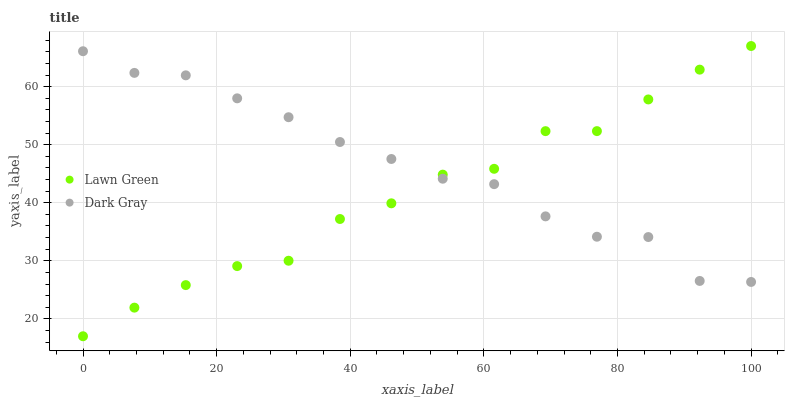Does Lawn Green have the minimum area under the curve?
Answer yes or no. Yes. Does Dark Gray have the maximum area under the curve?
Answer yes or no. Yes. Does Lawn Green have the maximum area under the curve?
Answer yes or no. No. Is Dark Gray the smoothest?
Answer yes or no. Yes. Is Lawn Green the roughest?
Answer yes or no. Yes. Is Lawn Green the smoothest?
Answer yes or no. No. Does Lawn Green have the lowest value?
Answer yes or no. Yes. Does Lawn Green have the highest value?
Answer yes or no. Yes. Does Lawn Green intersect Dark Gray?
Answer yes or no. Yes. Is Lawn Green less than Dark Gray?
Answer yes or no. No. Is Lawn Green greater than Dark Gray?
Answer yes or no. No. 